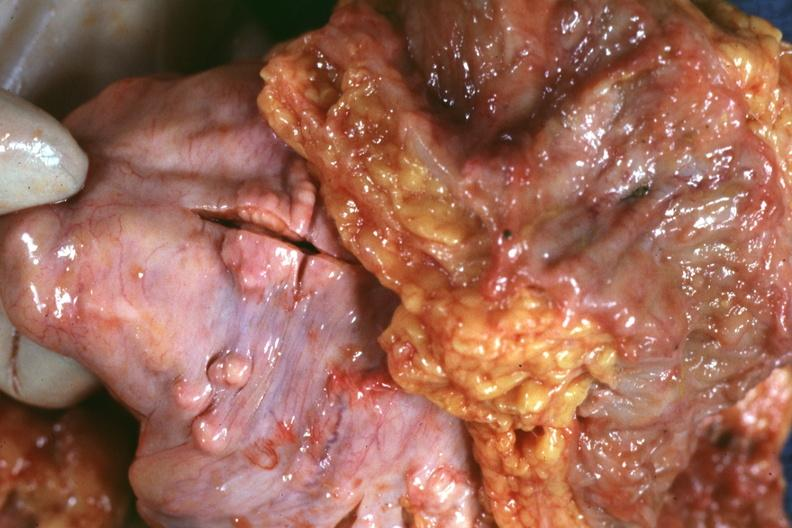does this image show view of rectovesical pouch with obvious tumor nodules beneath peritoneum very good example?
Answer the question using a single word or phrase. Yes 